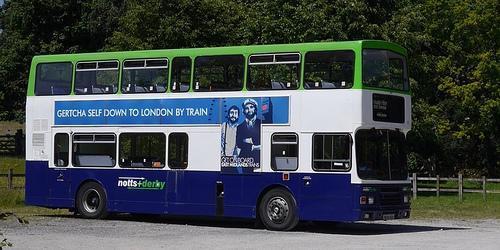How many buses have only 1 storyfloor?
Give a very brief answer. 0. 